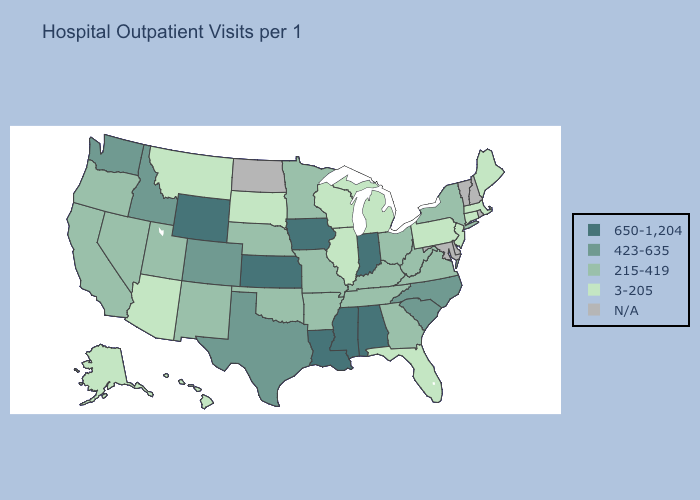What is the value of Louisiana?
Answer briefly. 650-1,204. Which states have the highest value in the USA?
Write a very short answer. Alabama, Indiana, Iowa, Kansas, Louisiana, Mississippi, Wyoming. Does New Jersey have the highest value in the Northeast?
Write a very short answer. No. Name the states that have a value in the range 650-1,204?
Short answer required. Alabama, Indiana, Iowa, Kansas, Louisiana, Mississippi, Wyoming. Name the states that have a value in the range N/A?
Short answer required. Delaware, Maryland, New Hampshire, North Dakota, Rhode Island, Vermont. What is the value of Kentucky?
Give a very brief answer. 215-419. What is the value of Arizona?
Short answer required. 3-205. Does Kentucky have the lowest value in the USA?
Short answer required. No. Name the states that have a value in the range 215-419?
Short answer required. Arkansas, California, Georgia, Kentucky, Minnesota, Missouri, Nebraska, Nevada, New Mexico, New York, Ohio, Oklahoma, Oregon, Tennessee, Utah, Virginia, West Virginia. Name the states that have a value in the range 650-1,204?
Quick response, please. Alabama, Indiana, Iowa, Kansas, Louisiana, Mississippi, Wyoming. What is the value of Alabama?
Keep it brief. 650-1,204. Does the first symbol in the legend represent the smallest category?
Keep it brief. No. Does Wyoming have the highest value in the West?
Quick response, please. Yes. Name the states that have a value in the range 423-635?
Answer briefly. Colorado, Idaho, North Carolina, South Carolina, Texas, Washington. 